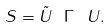Convert formula to latex. <formula><loc_0><loc_0><loc_500><loc_500>S = \tilde { U } \ \Gamma \ U .</formula> 